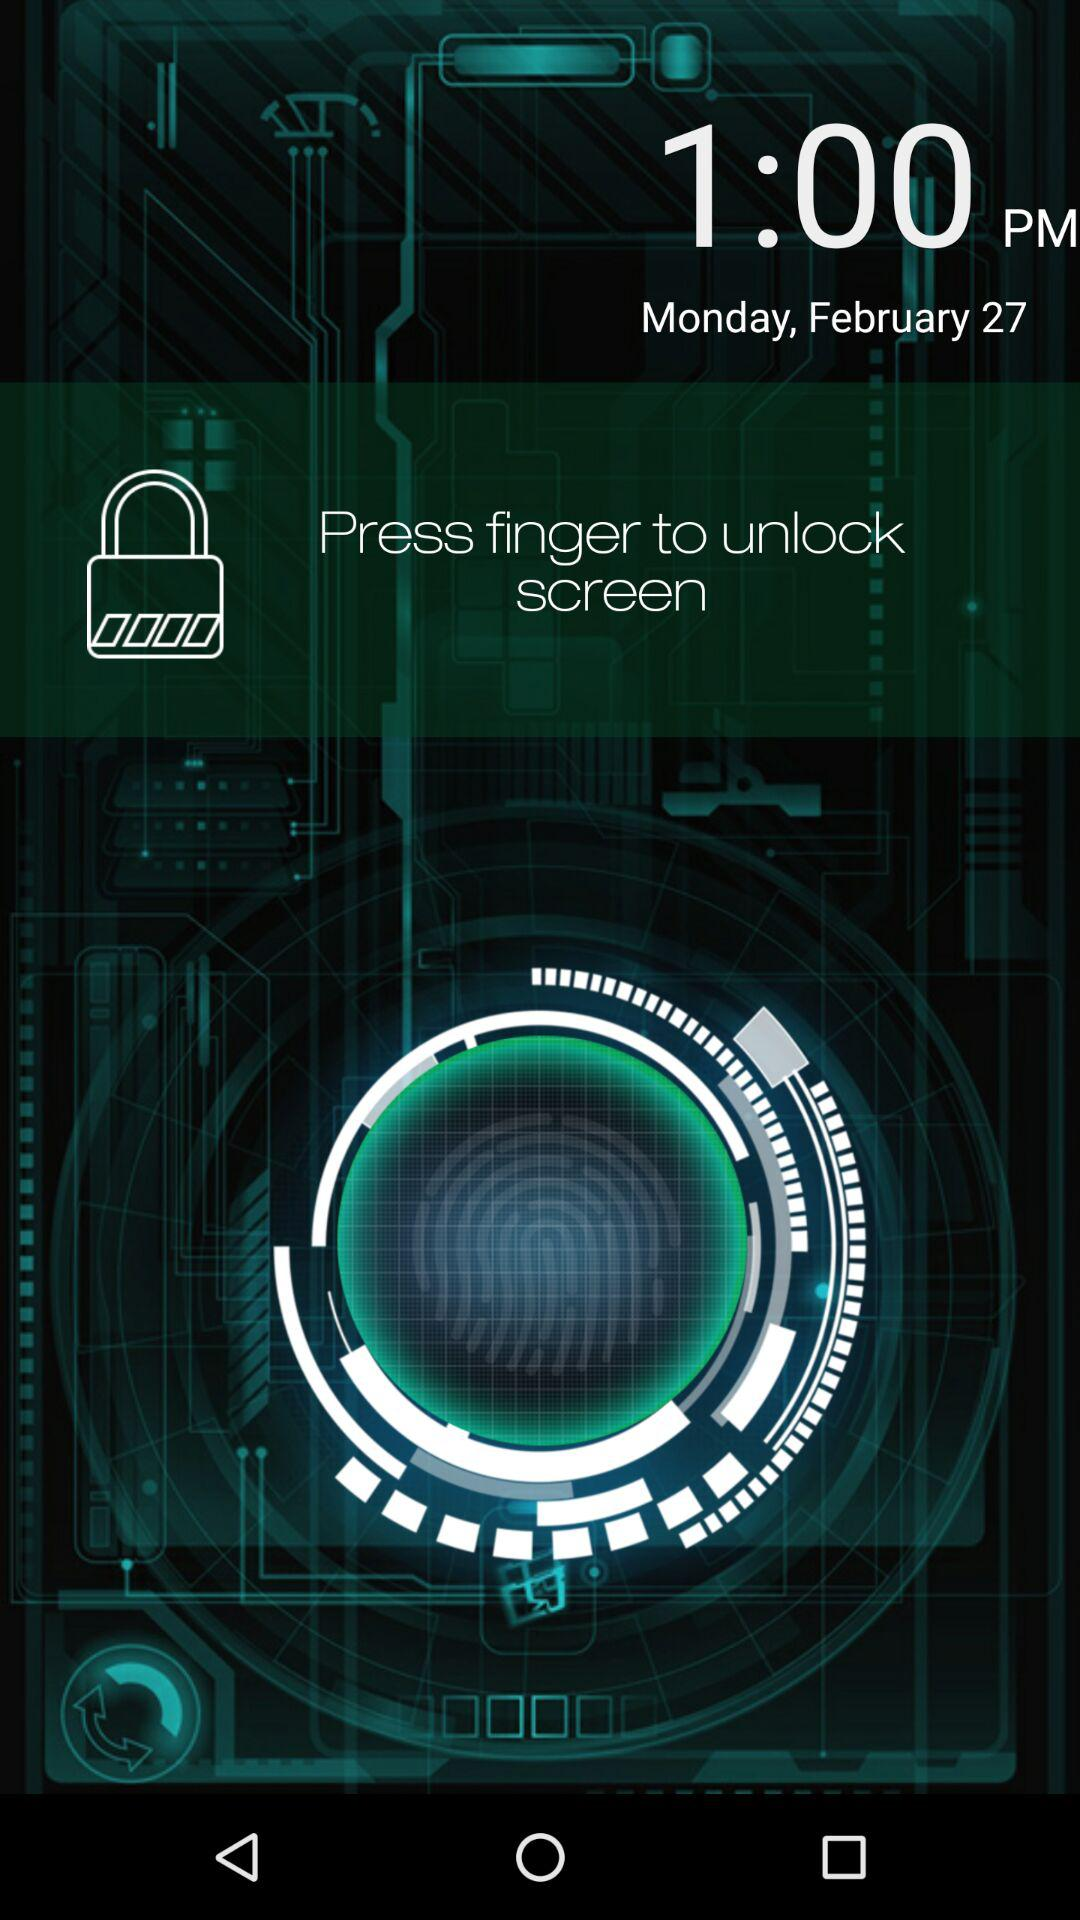What is the displayed day? The displayed day is Monday. 